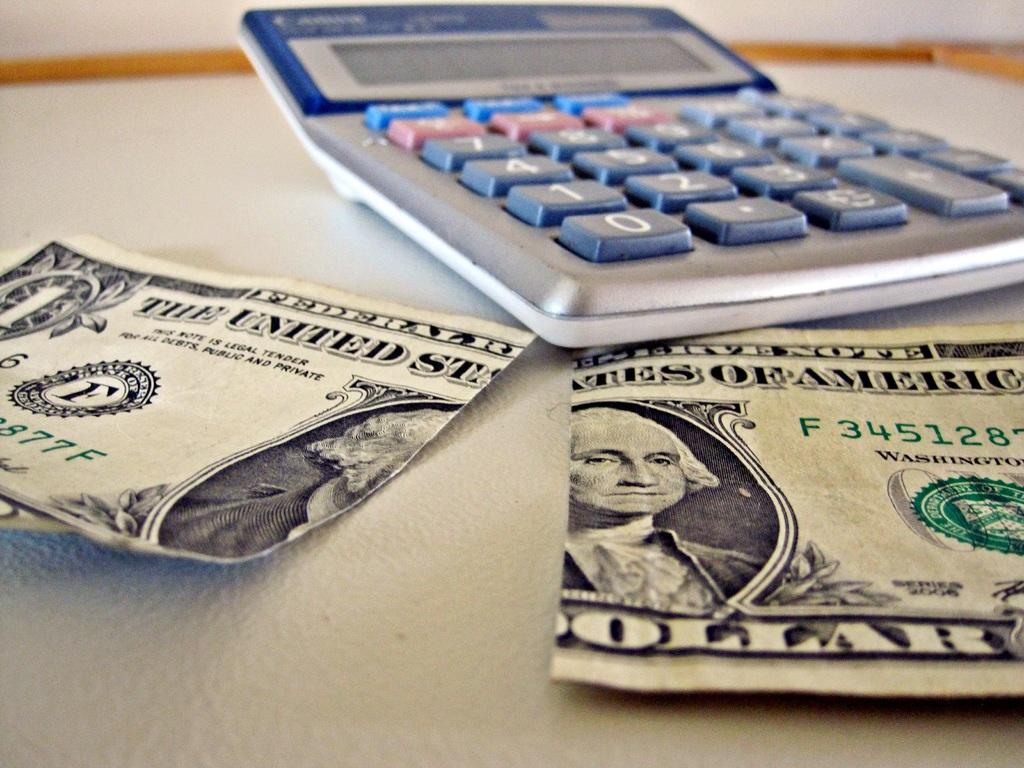<image>
Create a compact narrative representing the image presented. A dollar bill from the United States is ripped in half. 